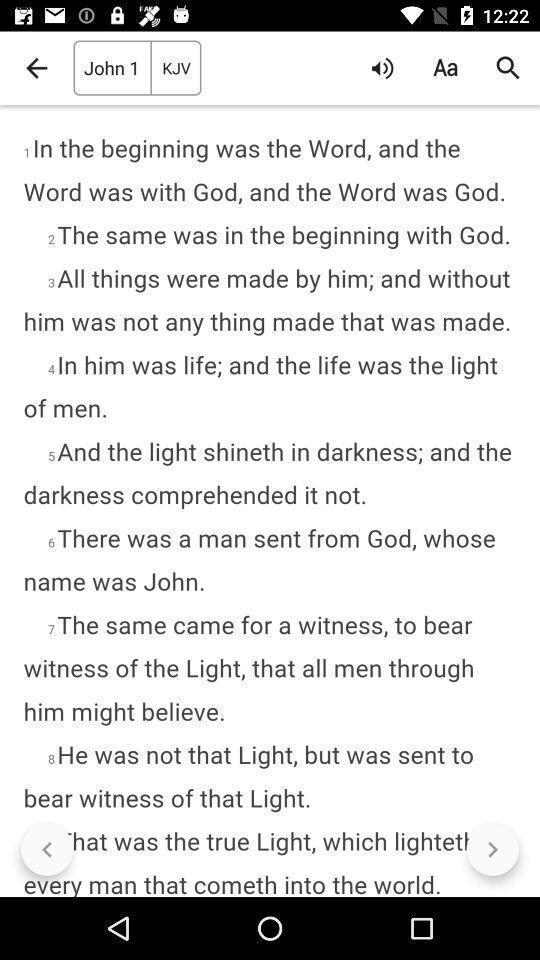Tell me what you see in this picture. Screen displaying page of an reading application. 